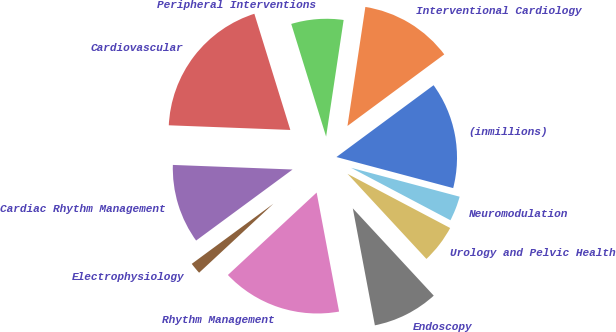<chart> <loc_0><loc_0><loc_500><loc_500><pie_chart><fcel>(inmillions)<fcel>Interventional Cardiology<fcel>Peripheral Interventions<fcel>Cardiovascular<fcel>Cardiac Rhythm Management<fcel>Electrophysiology<fcel>Rhythm Management<fcel>Endoscopy<fcel>Urology and Pelvic Health<fcel>Neuromodulation<nl><fcel>14.27%<fcel>12.49%<fcel>7.15%<fcel>19.61%<fcel>10.71%<fcel>1.81%<fcel>16.05%<fcel>8.93%<fcel>5.37%<fcel>3.59%<nl></chart> 